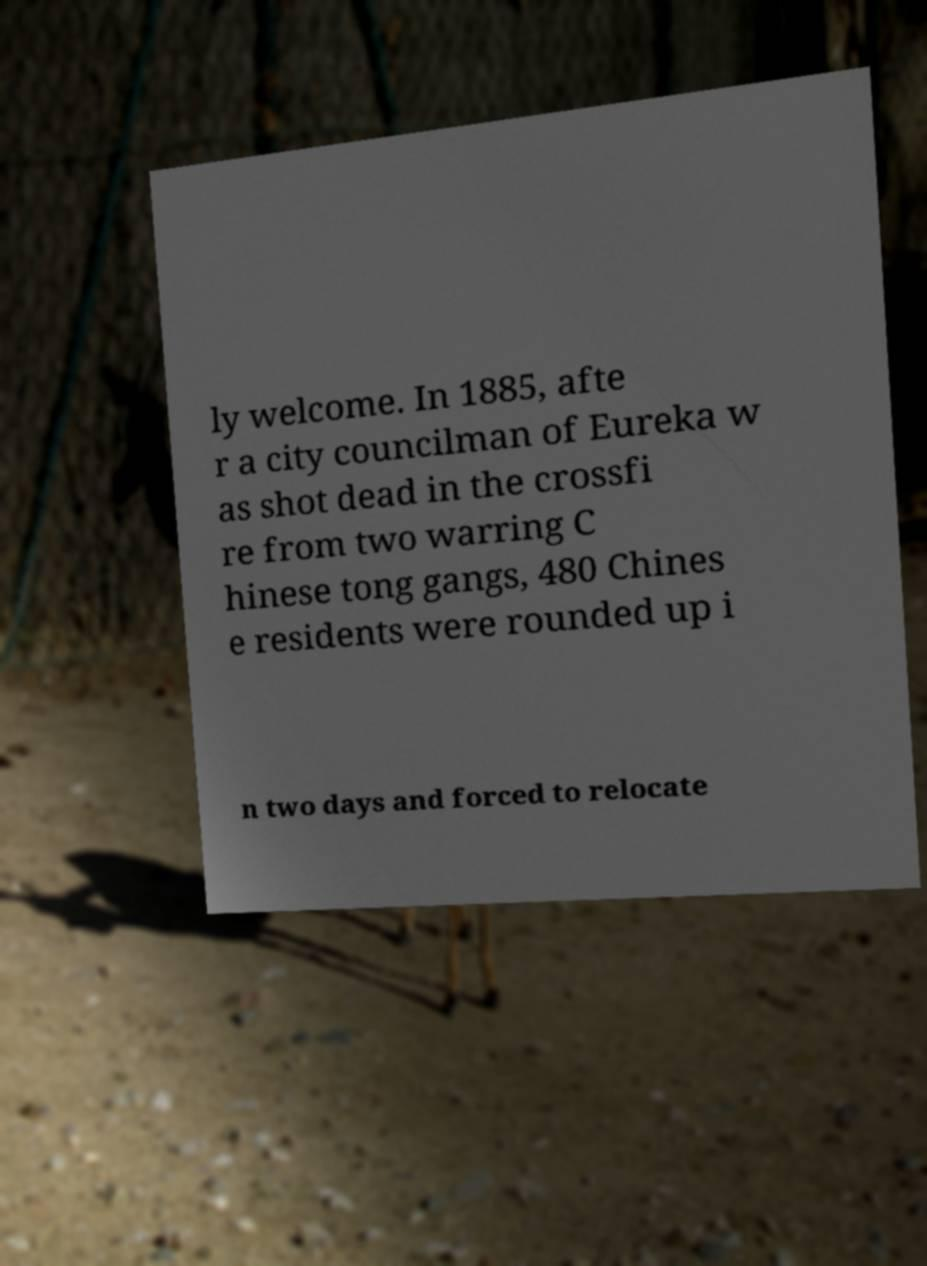For documentation purposes, I need the text within this image transcribed. Could you provide that? ly welcome. In 1885, afte r a city councilman of Eureka w as shot dead in the crossfi re from two warring C hinese tong gangs, 480 Chines e residents were rounded up i n two days and forced to relocate 